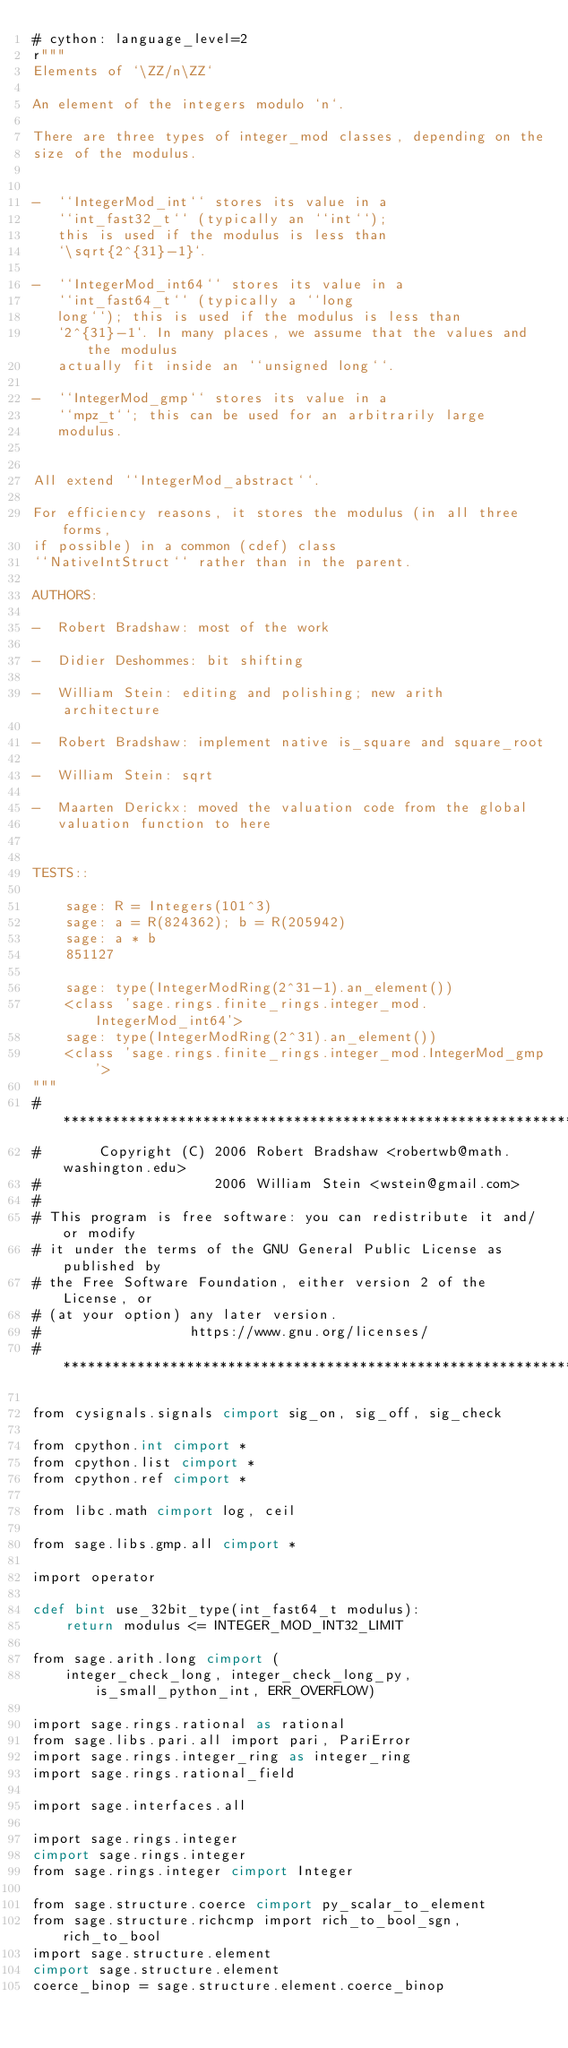<code> <loc_0><loc_0><loc_500><loc_500><_Cython_># cython: language_level=2
r"""
Elements of `\ZZ/n\ZZ`

An element of the integers modulo `n`.

There are three types of integer_mod classes, depending on the
size of the modulus.


-  ``IntegerMod_int`` stores its value in a
   ``int_fast32_t`` (typically an ``int``);
   this is used if the modulus is less than
   `\sqrt{2^{31}-1}`.

-  ``IntegerMod_int64`` stores its value in a
   ``int_fast64_t`` (typically a ``long
   long``); this is used if the modulus is less than
   `2^{31}-1`. In many places, we assume that the values and the modulus
   actually fit inside an ``unsigned long``.

-  ``IntegerMod_gmp`` stores its value in a
   ``mpz_t``; this can be used for an arbitrarily large
   modulus.


All extend ``IntegerMod_abstract``.

For efficiency reasons, it stores the modulus (in all three forms,
if possible) in a common (cdef) class
``NativeIntStruct`` rather than in the parent.

AUTHORS:

-  Robert Bradshaw: most of the work

-  Didier Deshommes: bit shifting

-  William Stein: editing and polishing; new arith architecture

-  Robert Bradshaw: implement native is_square and square_root

-  William Stein: sqrt

-  Maarten Derickx: moved the valuation code from the global
   valuation function to here


TESTS::

    sage: R = Integers(101^3)
    sage: a = R(824362); b = R(205942)
    sage: a * b
    851127

    sage: type(IntegerModRing(2^31-1).an_element())
    <class 'sage.rings.finite_rings.integer_mod.IntegerMod_int64'>
    sage: type(IntegerModRing(2^31).an_element())
    <class 'sage.rings.finite_rings.integer_mod.IntegerMod_gmp'>
"""
# ****************************************************************************
#       Copyright (C) 2006 Robert Bradshaw <robertwb@math.washington.edu>
#                     2006 William Stein <wstein@gmail.com>
#
# This program is free software: you can redistribute it and/or modify
# it under the terms of the GNU General Public License as published by
# the Free Software Foundation, either version 2 of the License, or
# (at your option) any later version.
#                  https://www.gnu.org/licenses/
# ****************************************************************************

from cysignals.signals cimport sig_on, sig_off, sig_check

from cpython.int cimport *
from cpython.list cimport *
from cpython.ref cimport *

from libc.math cimport log, ceil

from sage.libs.gmp.all cimport *

import operator

cdef bint use_32bit_type(int_fast64_t modulus):
    return modulus <= INTEGER_MOD_INT32_LIMIT

from sage.arith.long cimport (
    integer_check_long, integer_check_long_py, is_small_python_int, ERR_OVERFLOW)

import sage.rings.rational as rational
from sage.libs.pari.all import pari, PariError
import sage.rings.integer_ring as integer_ring
import sage.rings.rational_field

import sage.interfaces.all

import sage.rings.integer
cimport sage.rings.integer
from sage.rings.integer cimport Integer

from sage.structure.coerce cimport py_scalar_to_element
from sage.structure.richcmp import rich_to_bool_sgn, rich_to_bool
import sage.structure.element
cimport sage.structure.element
coerce_binop = sage.structure.element.coerce_binop</code> 